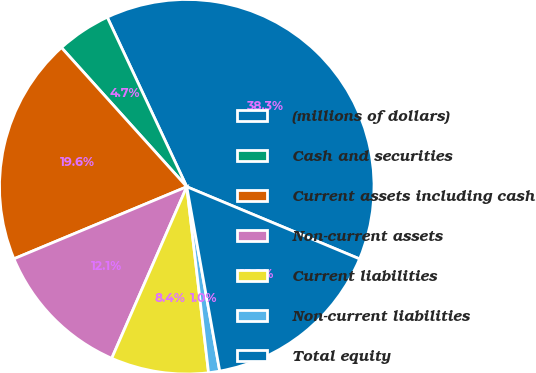<chart> <loc_0><loc_0><loc_500><loc_500><pie_chart><fcel>(millions of dollars)<fcel>Cash and securities<fcel>Current assets including cash<fcel>Non-current assets<fcel>Current liabilities<fcel>Non-current liabilities<fcel>Total equity<nl><fcel>38.28%<fcel>4.69%<fcel>19.62%<fcel>12.15%<fcel>8.42%<fcel>0.96%<fcel>15.89%<nl></chart> 